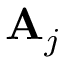<formula> <loc_0><loc_0><loc_500><loc_500>{ A } _ { j }</formula> 